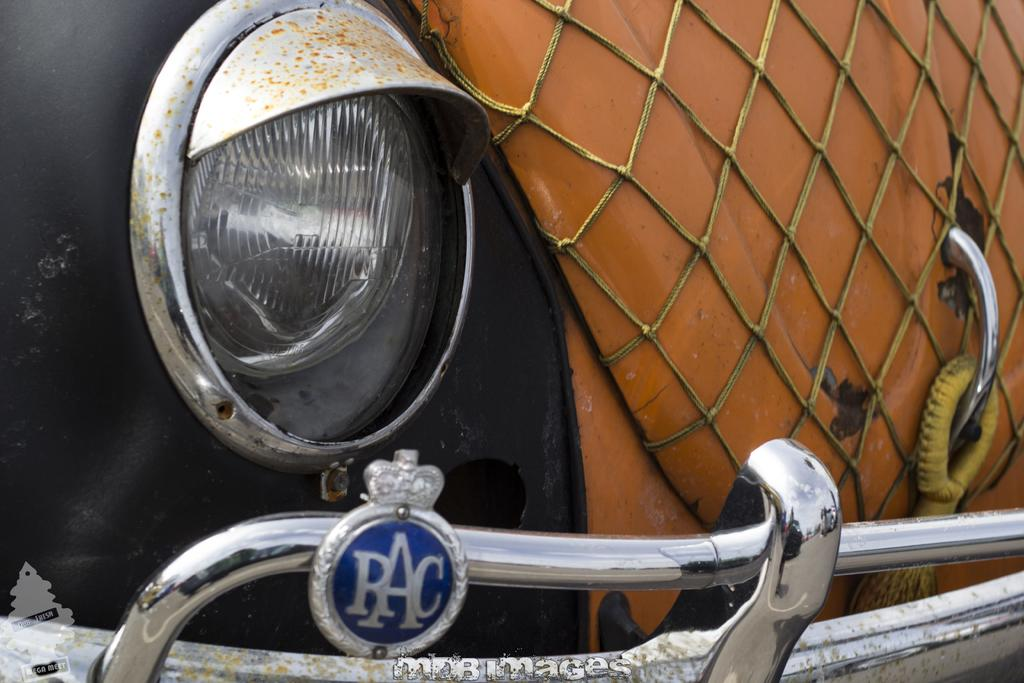What is the main subject of the image? The main subject of the image is a car. What specific features can be seen on the car? The car has a bumper and a headlight. How does the car appear in the image? The car appears to be damaged or truncated. Can you tell me how many firemen are standing next to the car in the image? There are no firemen present in the image; it only features a damaged or truncated car. What type of nut is being used to repair the car in the image? There is no nut being used to repair the car in the image; it appears to be damaged or truncated without any visible repair efforts. 